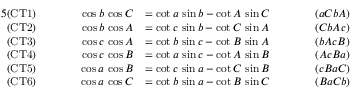<formula> <loc_0><loc_0><loc_500><loc_500>{ \begin{array} { r l r l r l } { { 5 } { ( C T 1 ) } } & { \quad \cos b \, \cos C } & { = \cot a \, \sin b - \cot A \, \sin C \quad } & & { ( a C b A ) } \\ { ( C T 2 ) } & { \cos b \, \cos A } & { = \cot c \, \sin b - \cot C \, \sin A } & & { ( C b A c ) } \\ { ( C T 3 ) } & { \cos c \, \cos A } & { = \cot b \, \sin c - \cot B \, \sin A } & & { ( b A c B ) } \\ { ( C T 4 ) } & { \cos c \, \cos B } & { = \cot a \, \sin c - \cot A \, \sin B } & & { ( A c B a ) } \\ { ( C T 5 ) } & { \cos a \, \cos B } & { = \cot c \, \sin a - \cot C \, \sin B } & & { ( c B a C ) } \\ { ( C T 6 ) } & { \cos a \, \cos C } & { = \cot b \, \sin a - \cot B \, \sin C } & & { ( B a C b ) } \end{array} }</formula> 